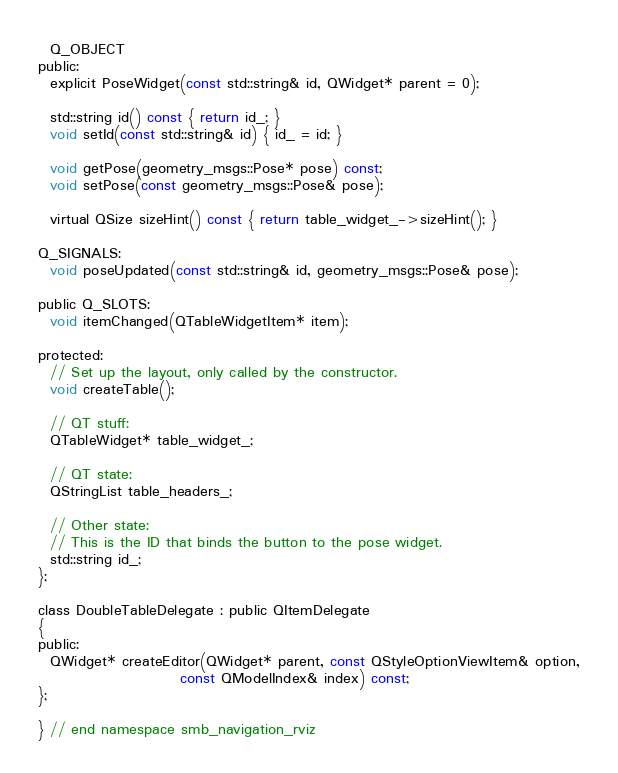<code> <loc_0><loc_0><loc_500><loc_500><_C_>  Q_OBJECT
public:
  explicit PoseWidget(const std::string& id, QWidget* parent = 0);

  std::string id() const { return id_; }
  void setId(const std::string& id) { id_ = id; }

  void getPose(geometry_msgs::Pose* pose) const;
  void setPose(const geometry_msgs::Pose& pose);

  virtual QSize sizeHint() const { return table_widget_->sizeHint(); }

Q_SIGNALS:
  void poseUpdated(const std::string& id, geometry_msgs::Pose& pose);

public Q_SLOTS:
  void itemChanged(QTableWidgetItem* item);

protected:
  // Set up the layout, only called by the constructor.
  void createTable();

  // QT stuff:
  QTableWidget* table_widget_;

  // QT state:
  QStringList table_headers_;

  // Other state:
  // This is the ID that binds the button to the pose widget.
  std::string id_;
};

class DoubleTableDelegate : public QItemDelegate
{
public:
  QWidget* createEditor(QWidget* parent, const QStyleOptionViewItem& option,
                        const QModelIndex& index) const;
};

} // end namespace smb_navigation_rviz
</code> 